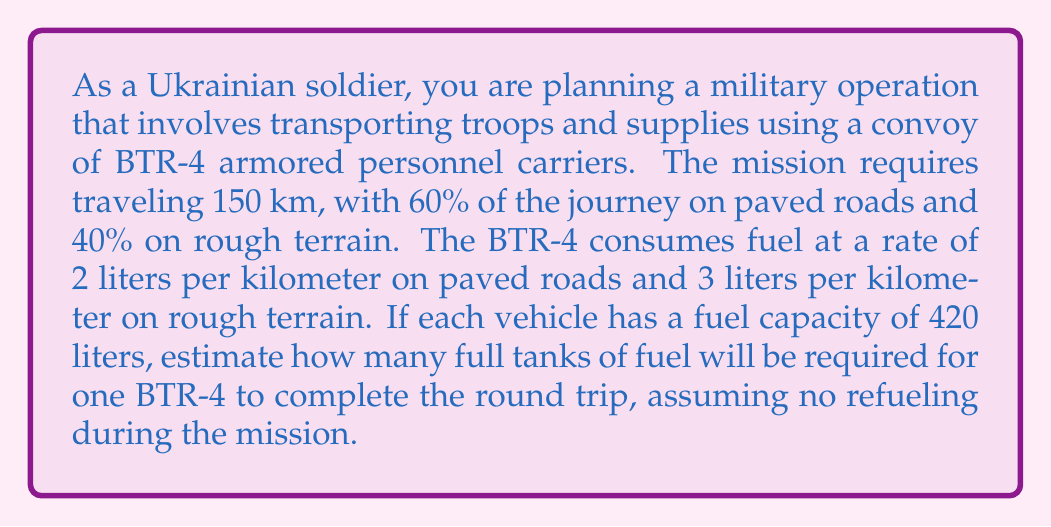Help me with this question. Let's break this problem down step-by-step:

1. Calculate the distance for each terrain type:
   Paved roads: $150 \text{ km} \times 0.60 = 90 \text{ km}$
   Rough terrain: $150 \text{ km} \times 0.40 = 60 \text{ km}$

2. Calculate fuel consumption for each terrain type (one way):
   Paved roads: $90 \text{ km} \times 2 \text{ L/km} = 180 \text{ L}$
   Rough terrain: $60 \text{ km} \times 3 \text{ L/km} = 180 \text{ L}$

3. Total fuel consumption for one way:
   $180 \text{ L} + 180 \text{ L} = 360 \text{ L}$

4. Calculate fuel consumption for round trip:
   $360 \text{ L} \times 2 = 720 \text{ L}$

5. Determine the number of full tanks required:
   $$\text{Number of tanks} = \left\lceil\frac{\text{Total fuel needed}}{\text{Tank capacity}}\right\rceil = \left\lceil\frac{720 \text{ L}}{420 \text{ L}}\right\rceil = \left\lceil1.714...\right\rceil = 2$$

The ceiling function $\lceil \rceil$ is used because we need to round up to the nearest whole number of tanks.
Answer: 2 full tanks of fuel 